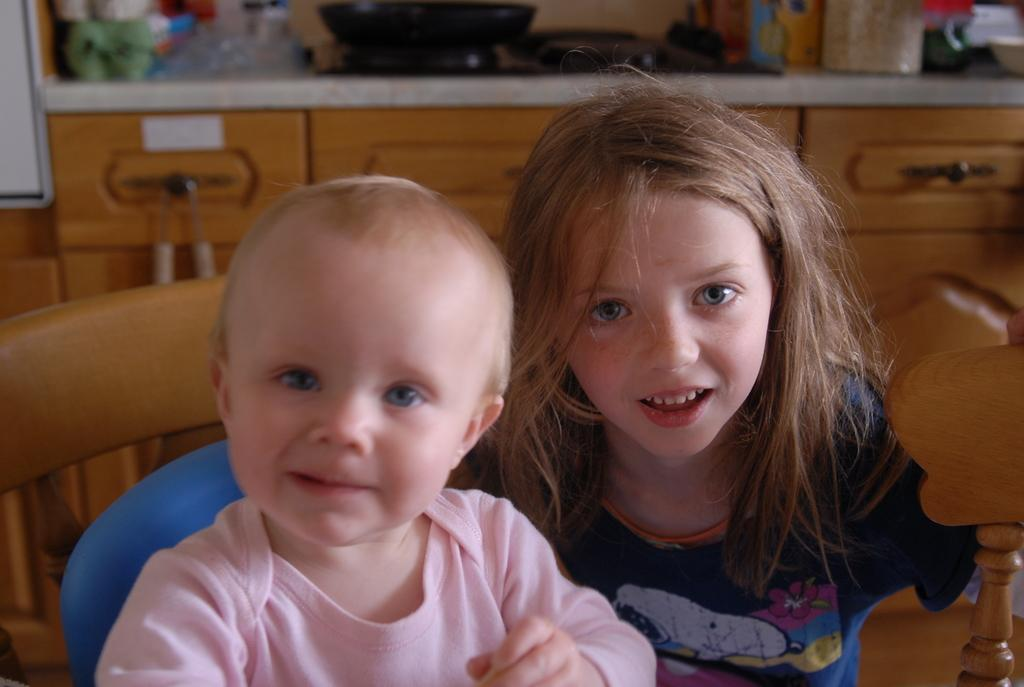How many children are in the image? There are two children in the image. What can be seen in the background of the image? There is a table with objects on it and a brown color cupboard in the background. Where is the coat rack located in the image? There is no coat rack present in the image. What type of soap can be seen in the image? There is no soap present in the image. 